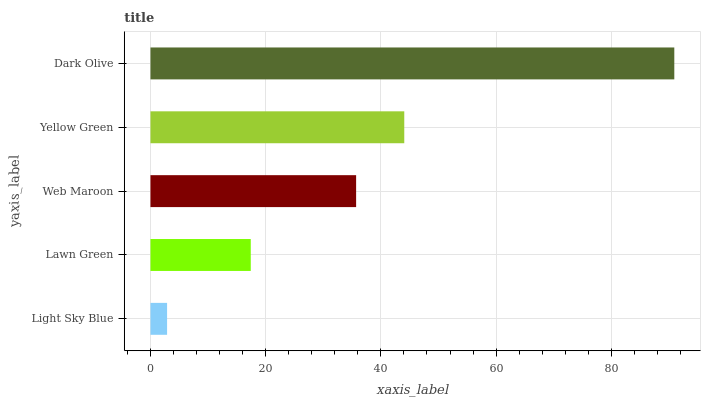Is Light Sky Blue the minimum?
Answer yes or no. Yes. Is Dark Olive the maximum?
Answer yes or no. Yes. Is Lawn Green the minimum?
Answer yes or no. No. Is Lawn Green the maximum?
Answer yes or no. No. Is Lawn Green greater than Light Sky Blue?
Answer yes or no. Yes. Is Light Sky Blue less than Lawn Green?
Answer yes or no. Yes. Is Light Sky Blue greater than Lawn Green?
Answer yes or no. No. Is Lawn Green less than Light Sky Blue?
Answer yes or no. No. Is Web Maroon the high median?
Answer yes or no. Yes. Is Web Maroon the low median?
Answer yes or no. Yes. Is Lawn Green the high median?
Answer yes or no. No. Is Yellow Green the low median?
Answer yes or no. No. 